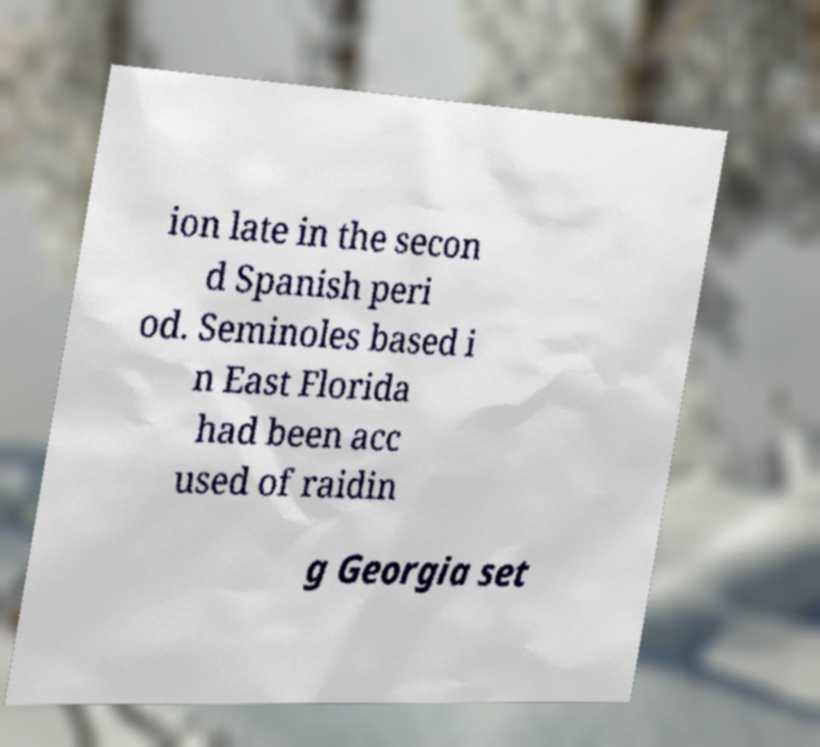Could you extract and type out the text from this image? ion late in the secon d Spanish peri od. Seminoles based i n East Florida had been acc used of raidin g Georgia set 